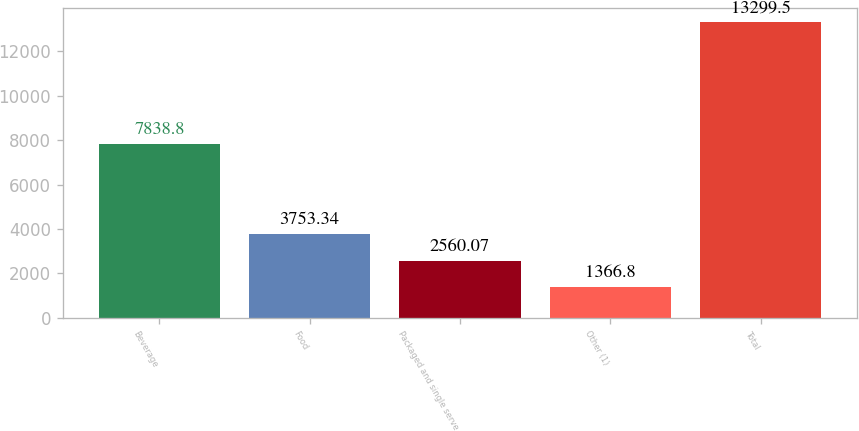Convert chart. <chart><loc_0><loc_0><loc_500><loc_500><bar_chart><fcel>Beverage<fcel>Food<fcel>Packaged and single serve<fcel>Other (1)<fcel>Total<nl><fcel>7838.8<fcel>3753.34<fcel>2560.07<fcel>1366.8<fcel>13299.5<nl></chart> 